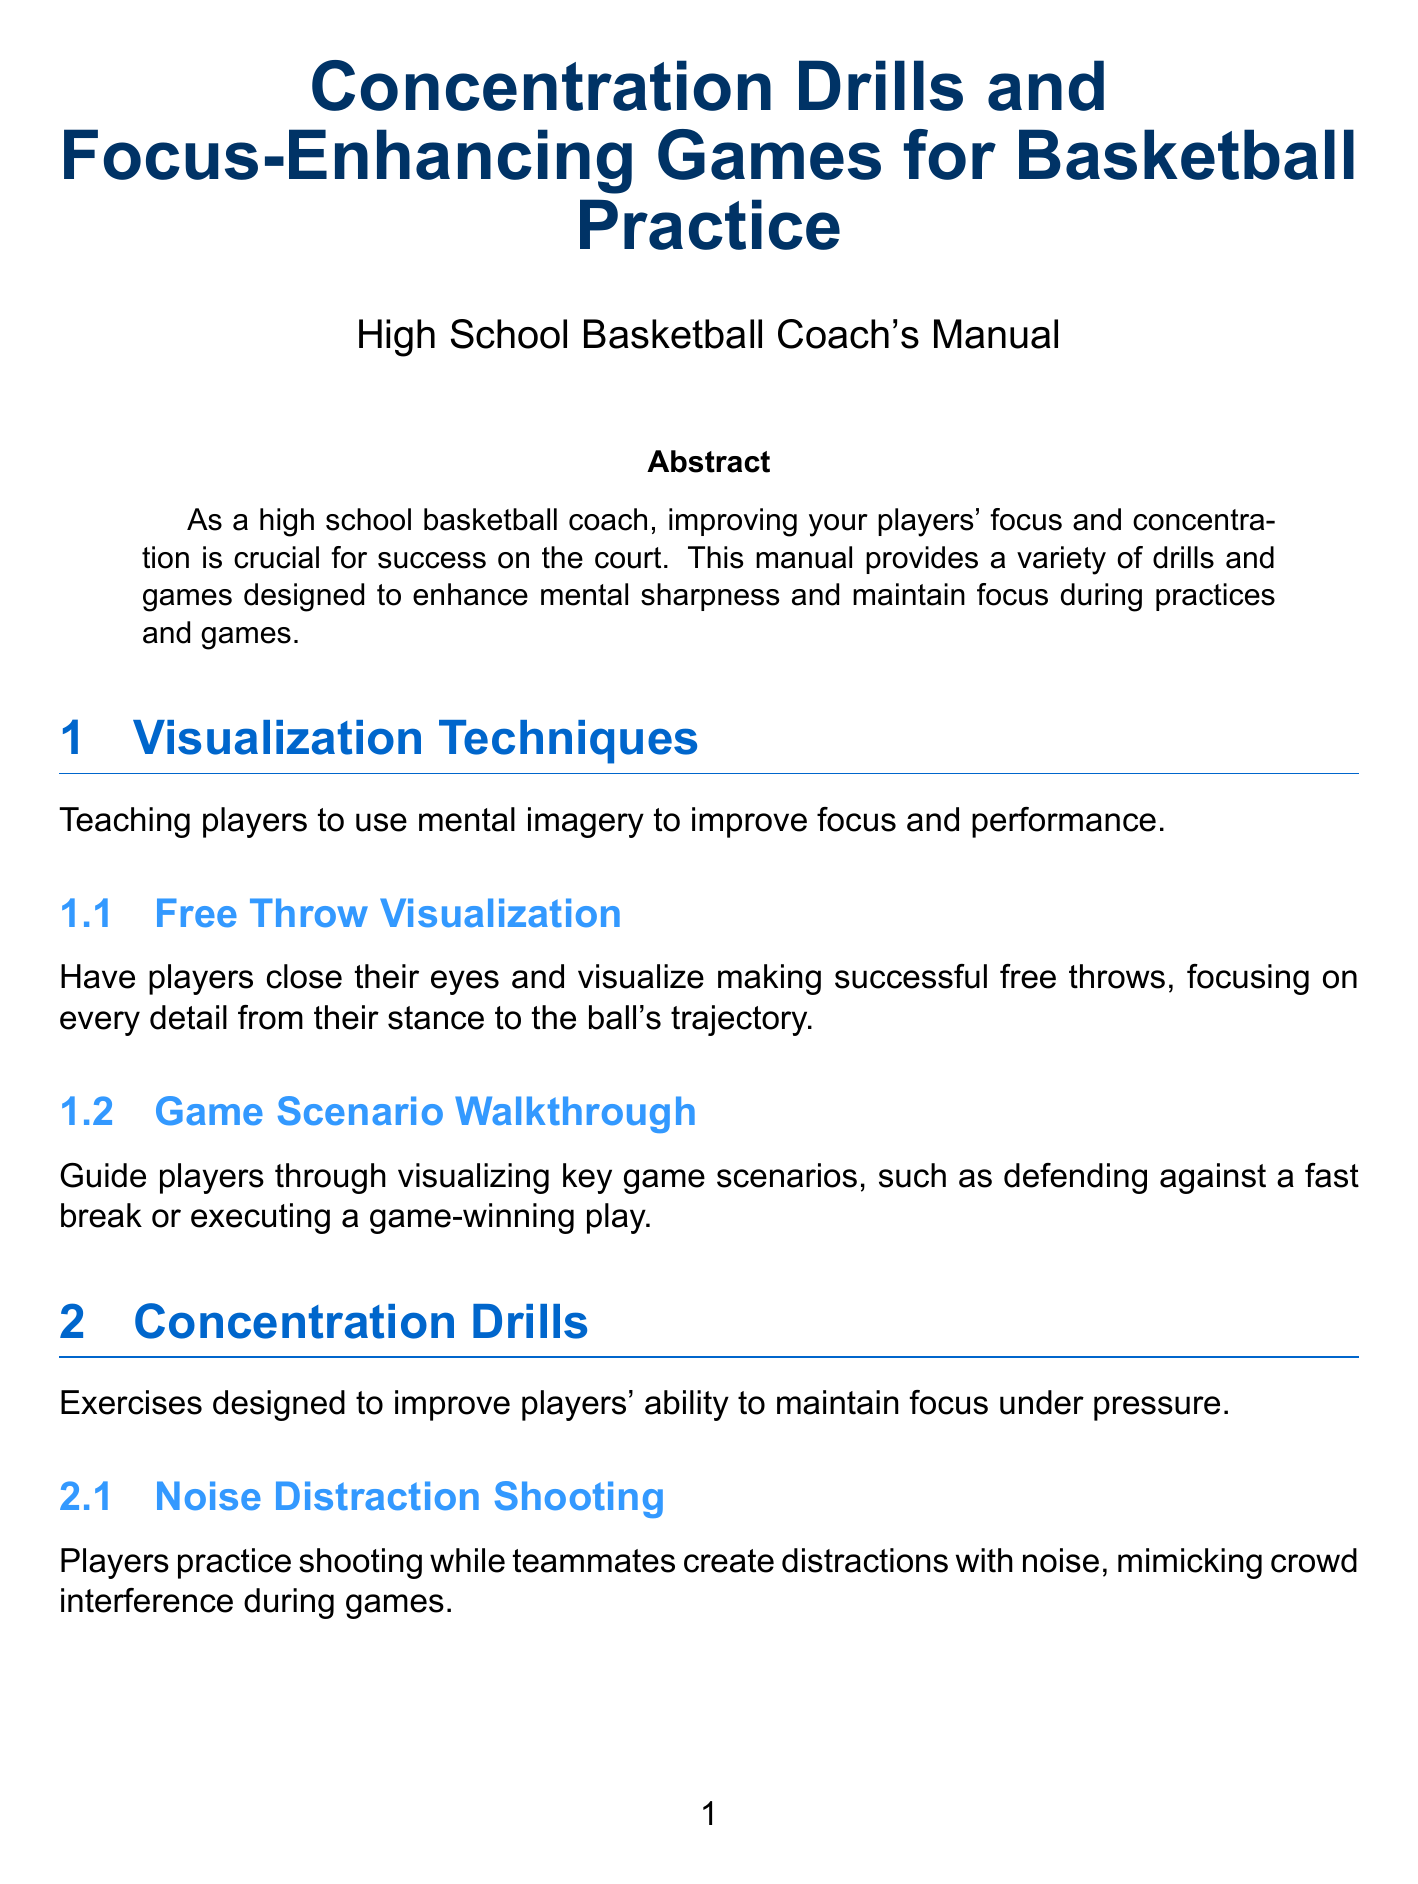What is the title of the manual? The title is stated at the beginning of the document.
Answer: Concentration Drills and Focus-Enhancing Games for Basketball Practice How many sections are in the manual? The document lists several sections which can be counted.
Answer: 5 What technique involves visualizing successful free throws? The specific activity is highlighted under the Visualization Techniques.
Answer: Free Throw Visualization Which breathing technique is included in the mindfulness section? The manual specifies several techniques, including the one asked about.
Answer: 4-7-8 Breathing Technique What game requires players to remember pass sequences? This activity is mentioned under Focus-Enhancing Games.
Answer: Memory Passing Sequence What is the goal of the Silent Scrimmage? The objective of the activity is described in the Team Focus Challenges section.
Answer: Focus on non-verbal cues Name one activity that promotes present-moment awareness. The relevant activity is mentioned in the Concentration Drills section.
Answer: Mindful Ball Handling How long should players hold their breath in the 4-7-8 Breathing Technique? The specific duration is provided in the mindfulness section's instructions.
Answer: 7 seconds What does the Body Scan Meditation promote? The intention behind the technique is explained in the mindfulness section.
Answer: Relaxation and awareness 